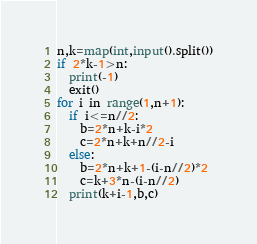Convert code to text. <code><loc_0><loc_0><loc_500><loc_500><_Python_>n,k=map(int,input().split())
if 2*k-1>n:
  print(-1)
  exit()
for i in range(1,n+1):
  if i<=n//2:
    b=2*n+k-i*2
    c=2*n+k+n//2-i
  else:
    b=2*n+k+1-(i-n//2)*2
    c=k+3*n-(i-n//2)
  print(k+i-1,b,c)
</code> 